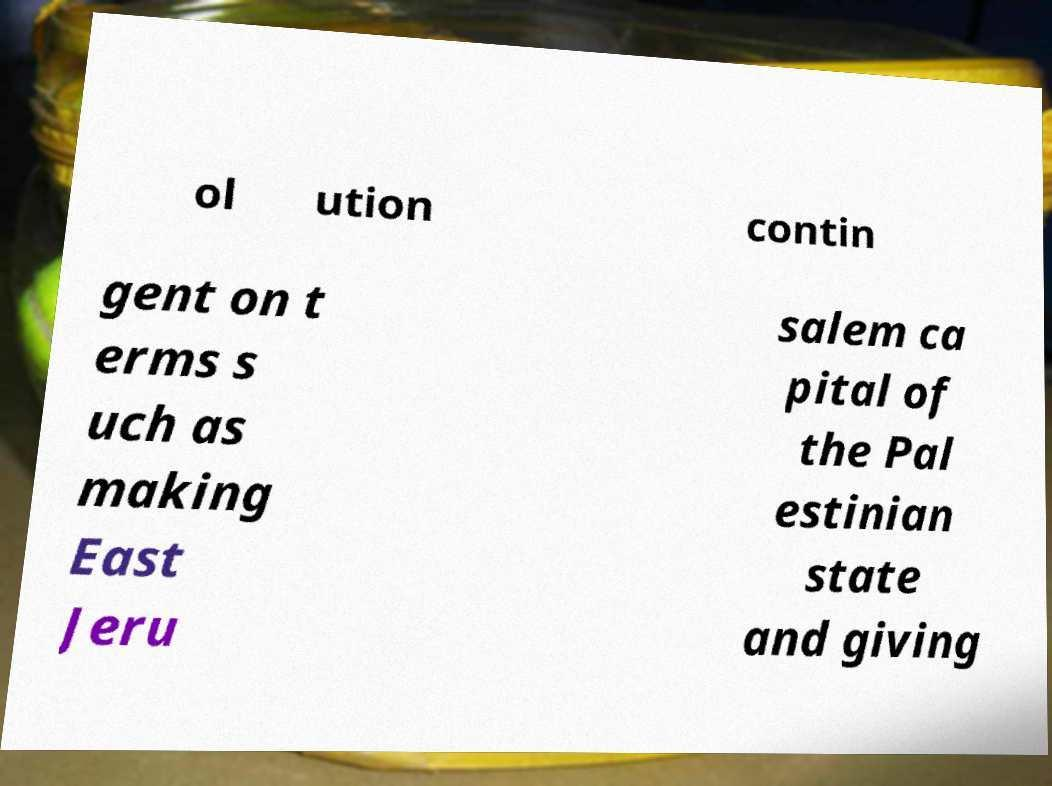There's text embedded in this image that I need extracted. Can you transcribe it verbatim? ol ution contin gent on t erms s uch as making East Jeru salem ca pital of the Pal estinian state and giving 